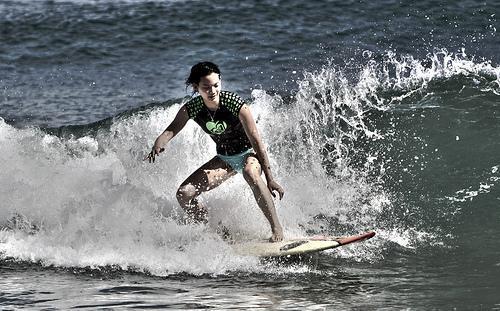How many people are surfing?
Give a very brief answer. 1. 